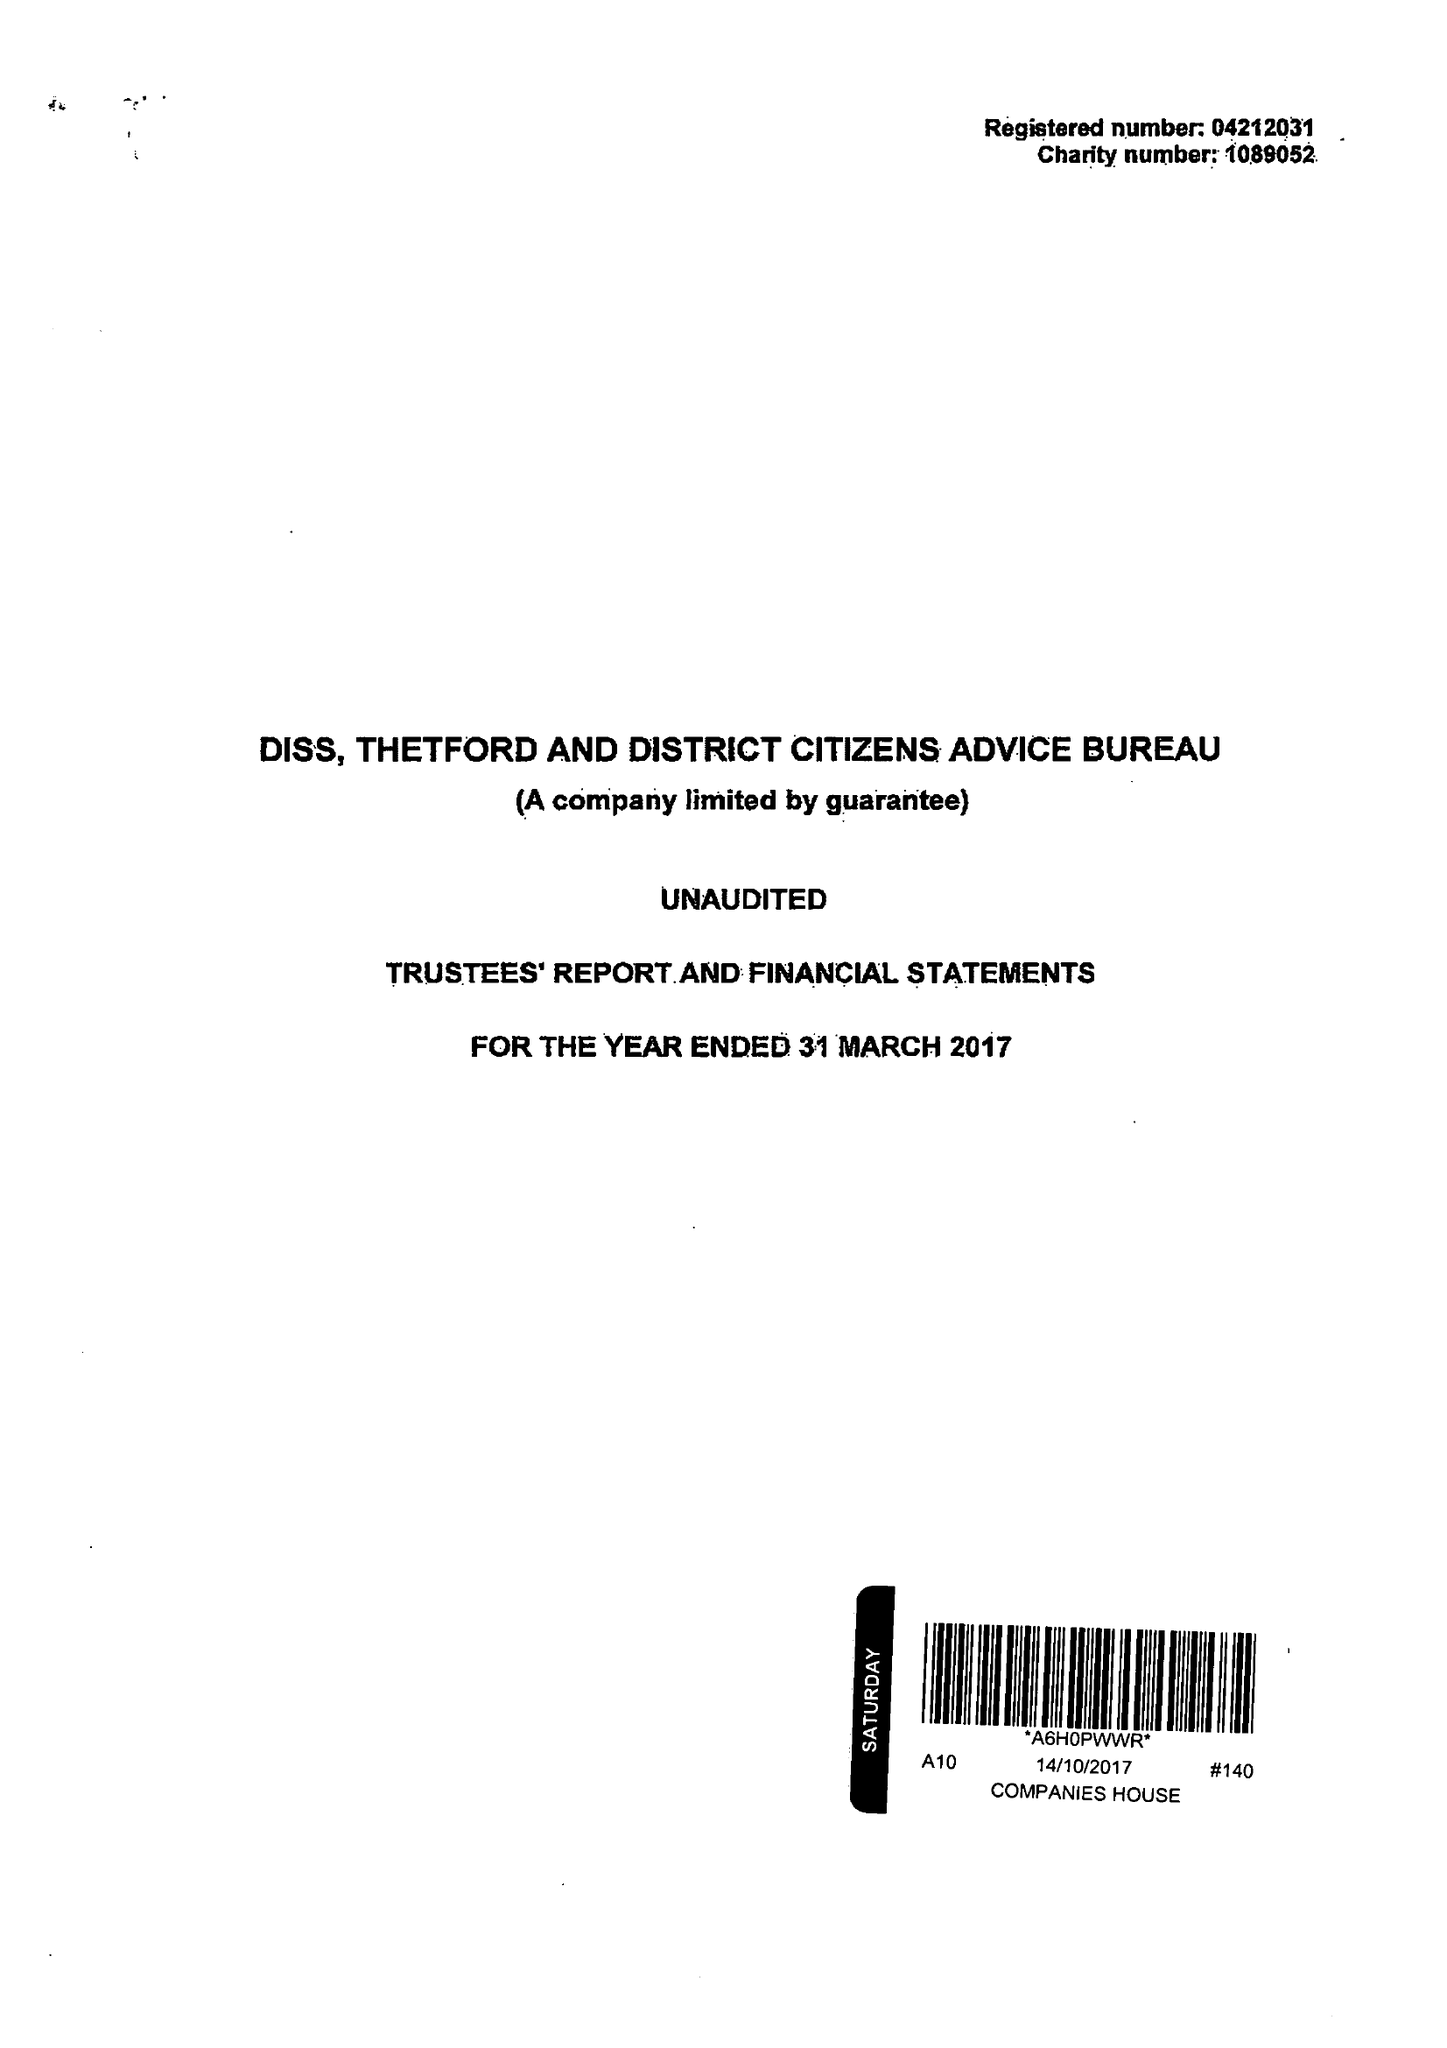What is the value for the charity_number?
Answer the question using a single word or phrase. 1089052 